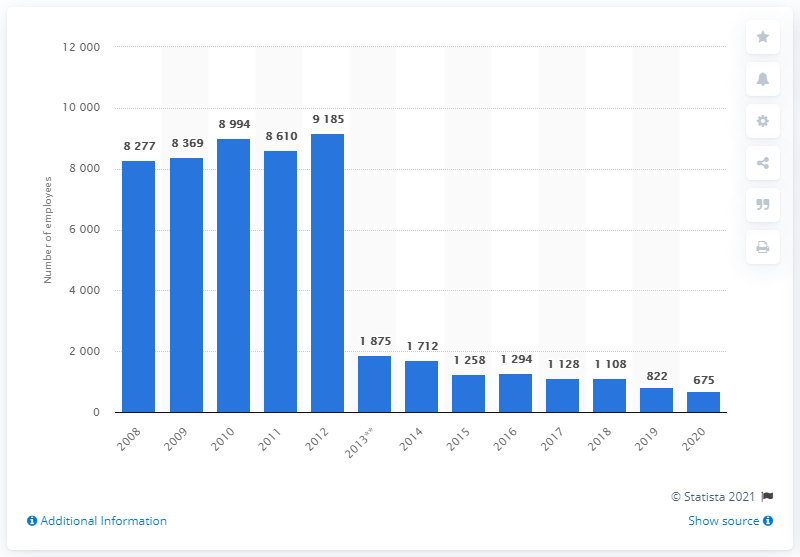Give some essential details in this illustration. As of 2020, Murphy Oil Corporation employed approximately 675 people. Murphy Oil Corporation employed 822 employees in the year prior. 